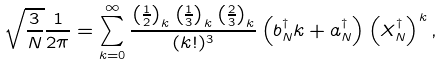<formula> <loc_0><loc_0><loc_500><loc_500>\sqrt { \frac { 3 } { N } } \frac { 1 } { 2 \pi } = \sum _ { k = 0 } ^ { \infty } \frac { \left ( \frac { 1 } { 2 } \right ) _ { k } \left ( \frac { 1 } { 3 } \right ) _ { k } \left ( \frac { 2 } { 3 } \right ) _ { k } } { ( k ! ) ^ { 3 } } \left ( b ^ { \dagger } _ { N } k + a ^ { \dagger } _ { N } \right ) \left ( X ^ { \dagger } _ { N } \right ) ^ { k } ,</formula> 